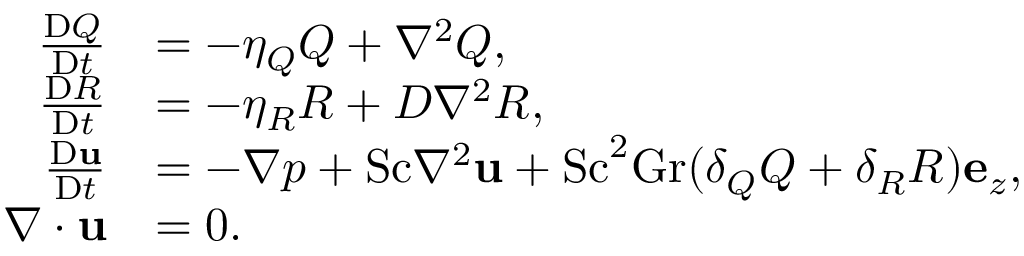<formula> <loc_0><loc_0><loc_500><loc_500>\begin{array} { r l } { \frac { D Q } { D t } } & { = - \eta _ { Q } Q + \nabla ^ { 2 } Q , } \\ { \frac { D R } { D t } } & { = - \eta _ { R } R + D \nabla ^ { 2 } R , } \\ { \frac { D u } { D t } } & { = - \nabla p + S c \nabla ^ { 2 } u + S c ^ { 2 } G r ( \delta _ { Q } Q + \delta _ { R } R ) e _ { z } , } \\ { \nabla \cdot u } & { = 0 . } \end{array}</formula> 